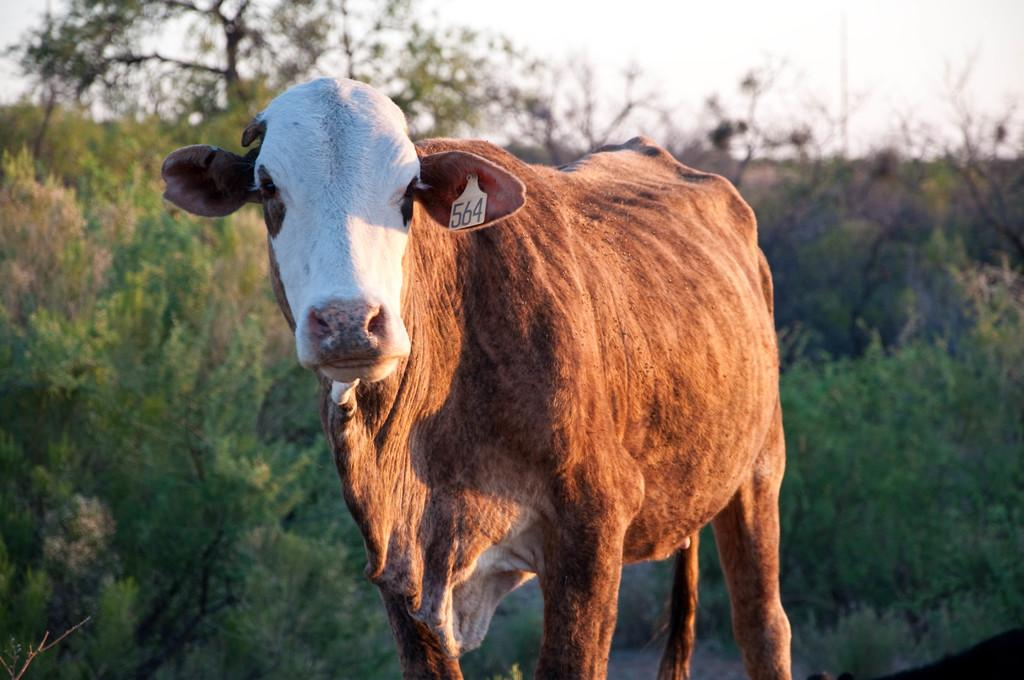What type of animal is in the image? There is an animal in the image, but its specific type cannot be determined from the provided facts. Can you describe the color of the animal? The animal has a white and brown color. What is unique about the animal in the image? The animal has a badge. What can be seen in the background of the image? There are many trees in the background of the image. What is the color of the sky in the image? The sky is white in the image. What type of soup is being served for breakfast in the image? There is no soup or breakfast depicted in the image; it features an animal with a badge and a white and brown color. Who is the servant attending to in the image? There is no servant or person being attended to in the image. 